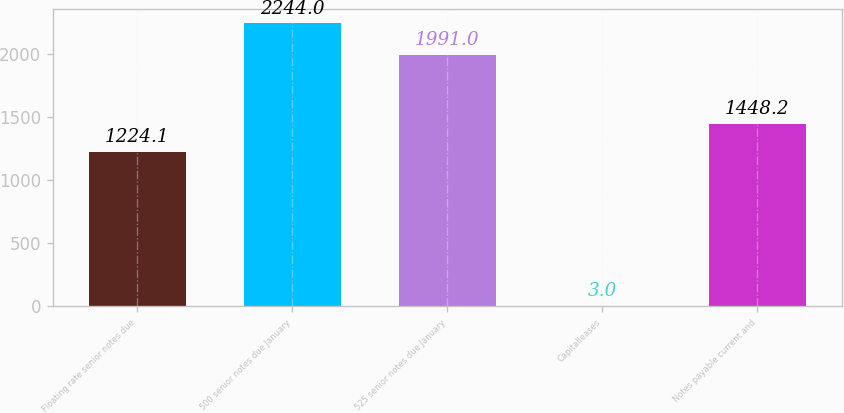<chart> <loc_0><loc_0><loc_500><loc_500><bar_chart><fcel>Floating rate senior notes due<fcel>500 senior notes due January<fcel>525 senior notes due January<fcel>Capitalleases<fcel>Notes payable current and<nl><fcel>1224.1<fcel>2244<fcel>1991<fcel>3<fcel>1448.2<nl></chart> 